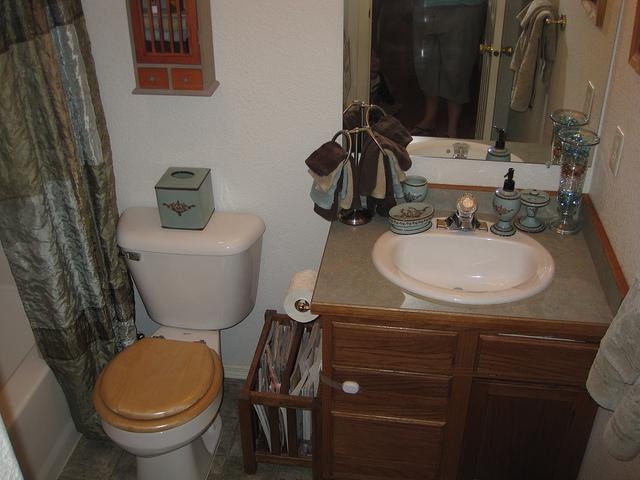What is the box on the toilet tank used for?

Choices:
A) shampoo storage
B) soap
C) cotton balls
D) tissue boxes tissue boxes 